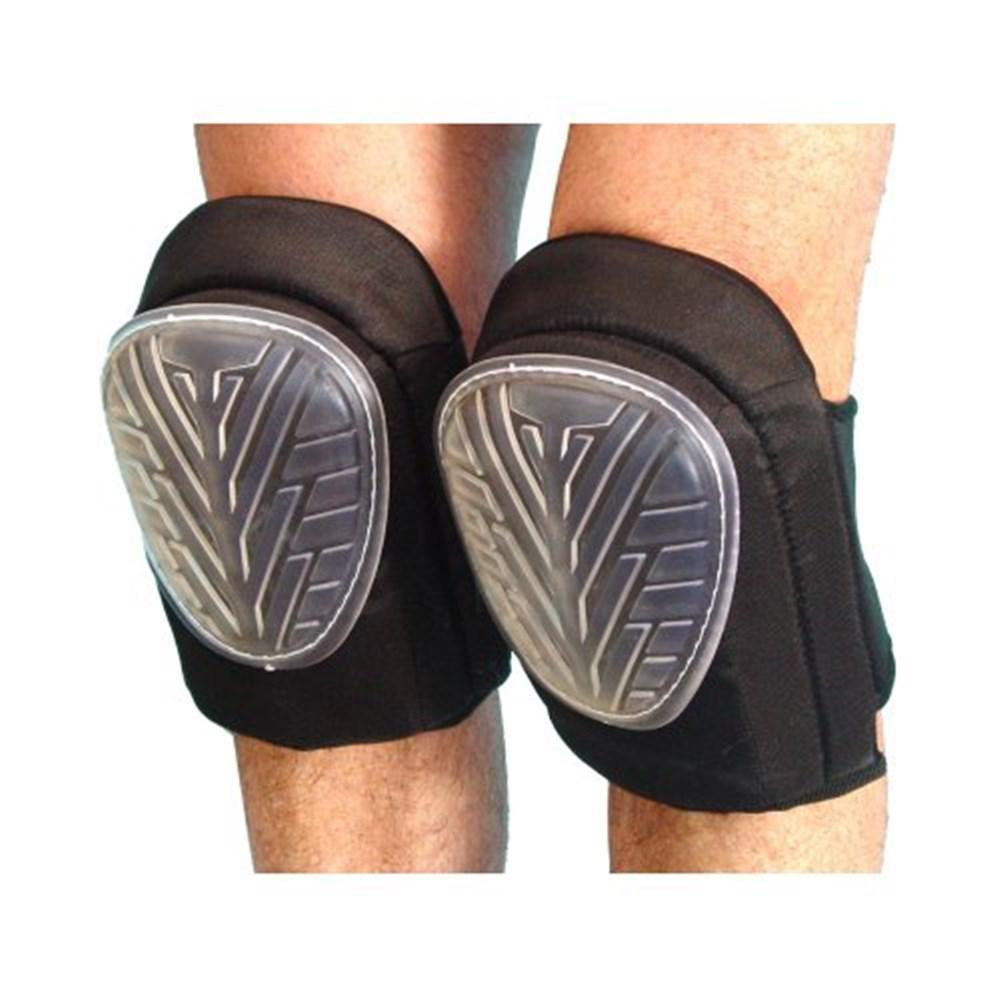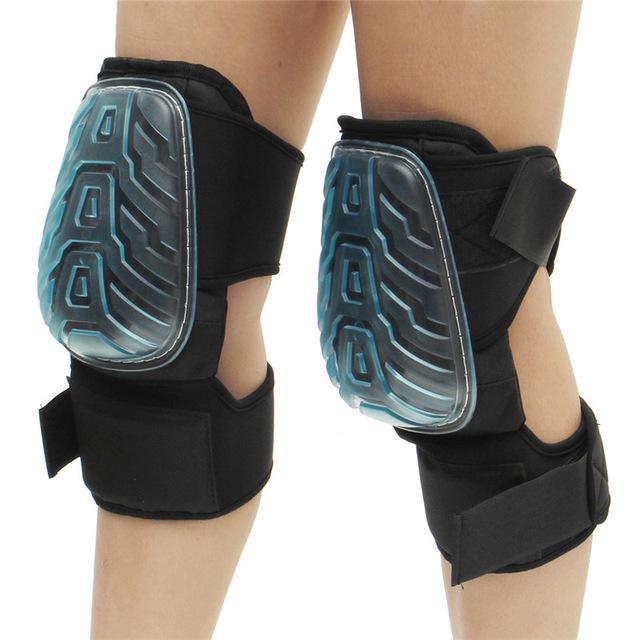The first image is the image on the left, the second image is the image on the right. Given the left and right images, does the statement "There are exactly two knee braces." hold true? Answer yes or no. No. The first image is the image on the left, the second image is the image on the right. Considering the images on both sides, is "The right image contains no more than one knee brace." valid? Answer yes or no. No. 